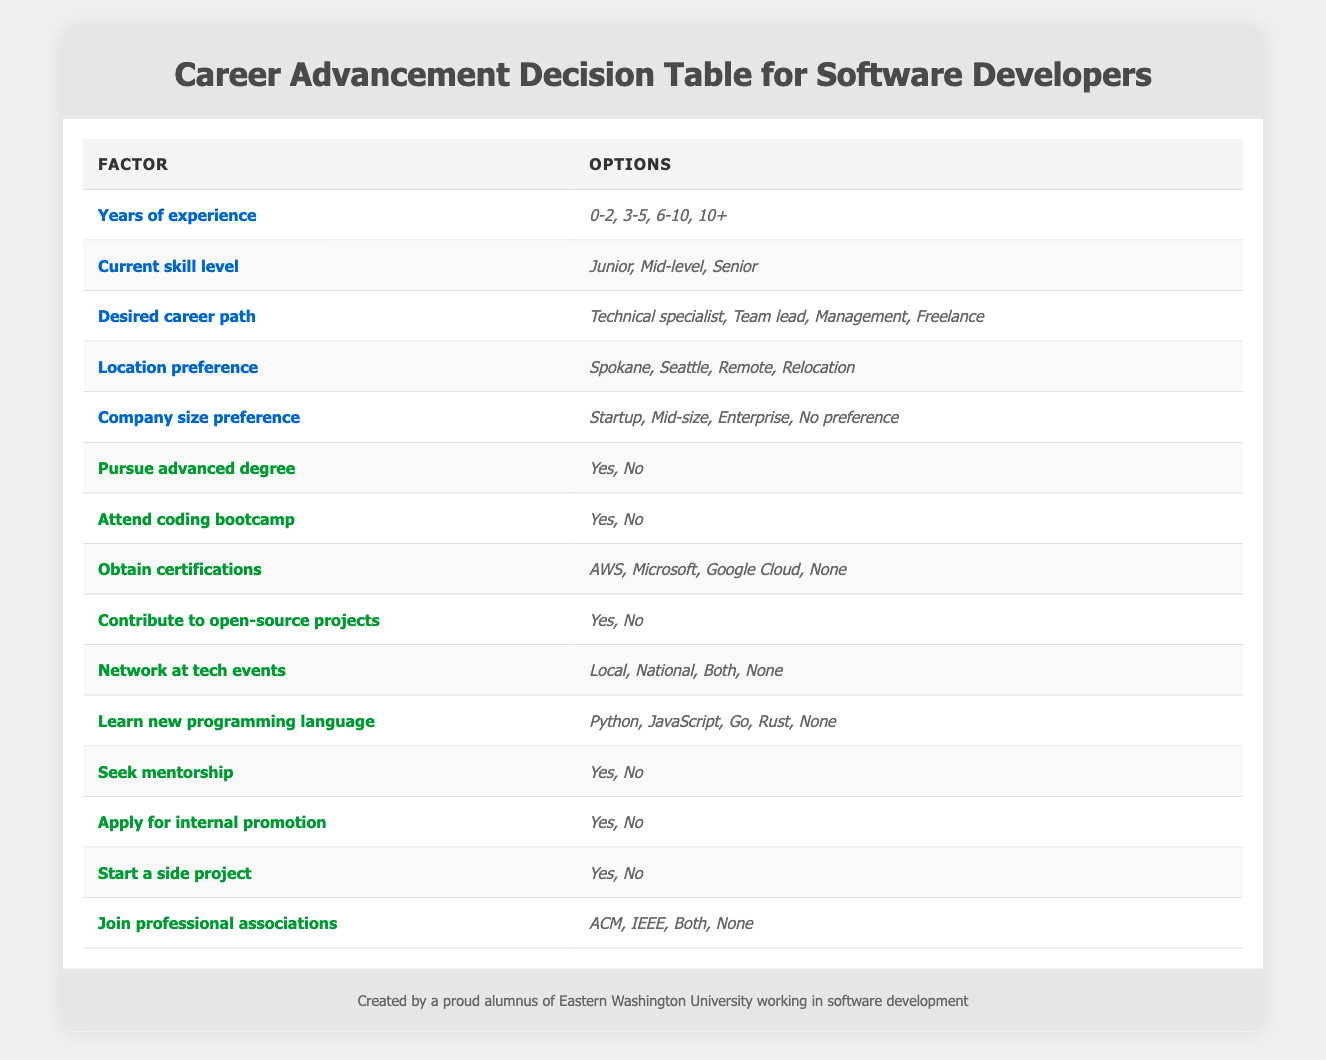What are the options for 'Desired career path'? The table states that the options for 'Desired career path' are 'Technical specialist', 'Team lead', 'Management', and 'Freelance'.
Answer: Technical specialist, Team lead, Management, Freelance Is obtaining AWS certifications listed as an action? Yes, according to the table, obtaining AWS certifications is one of the actions available, among other certification options.
Answer: Yes How many options are available for 'Location preference'? The table enumerates four options under 'Location preference': 'Spokane', 'Seattle', 'Remote', and 'Relocation'. Thus, there are four options.
Answer: Four If a developer has 0-2 years of experience and is looking for a management career path, can they pursue an advanced degree? Yes, pursuing an advanced degree is listed as an action, and there are no restrictions noted in the table concerning years of experience or career paths for this particular option.
Answer: Yes What is the average number of options listed for the 'actions' category? There are ten action options listed in the table. Taking them into consideration, the average remains ten since we count every option as one. Therefore, the average is simply 10/10 equal to 1 option per action.
Answer: 1 What combination can you consider if the current skill level is 'Senior' and the desired career path is 'Technical specialist'? The table doesn’t restrict actions based on these specific factors. A senior developer can pursue any listed action like obtaining certifications (AWS, Microsoft, etc.), contributing to open-source projects, and seeking mentorship. Thus, actionable combinations include obtaining certifications and contributing to open-source projects.
Answer: Multiple options available Is 'Network at tech events' one of the actions listed? Yes, the table includes 'Network at tech events' as one of the actions, with options about the scale of the events.
Answer: Yes What is the total number of conditions present in the table? The conditions include 'Years of experience', 'Current skill level', 'Desired career path', 'Location preference', and 'Company size preference', making a total of five distinct conditions.
Answer: Five What action requires a 'Yes' or 'No' decision related to professional associations? The action 'Join professional associations' requires a 'Yes' or 'No' decision, with further options being ACM, IEEE, Both, or None.
Answer: Join professional associations 